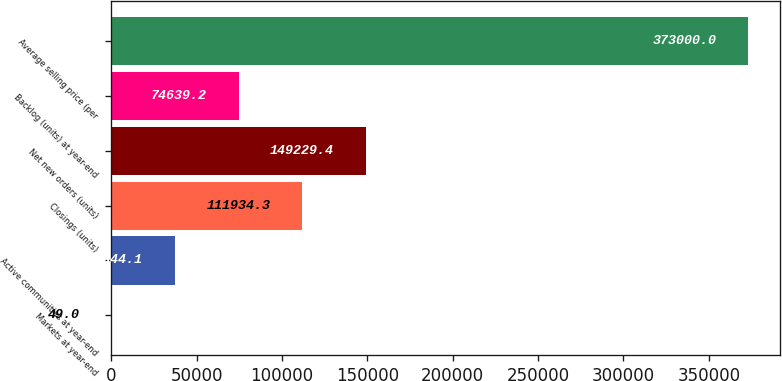Convert chart. <chart><loc_0><loc_0><loc_500><loc_500><bar_chart><fcel>Markets at year-end<fcel>Active communities at year-end<fcel>Closings (units)<fcel>Net new orders (units)<fcel>Backlog (units) at year-end<fcel>Average selling price (per<nl><fcel>49<fcel>37344.1<fcel>111934<fcel>149229<fcel>74639.2<fcel>373000<nl></chart> 